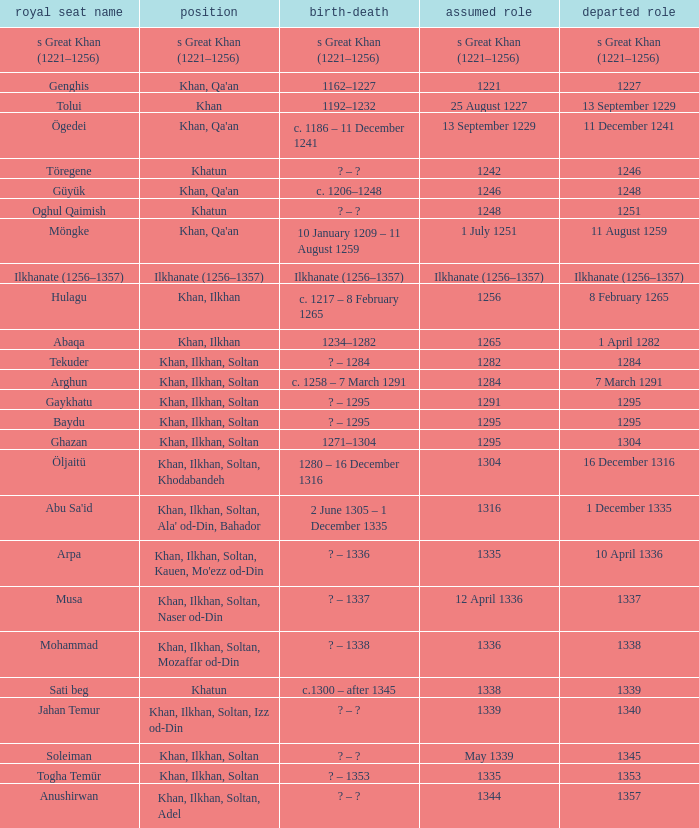What is the entered office that has 1337 as the left office? 12 April 1336. 